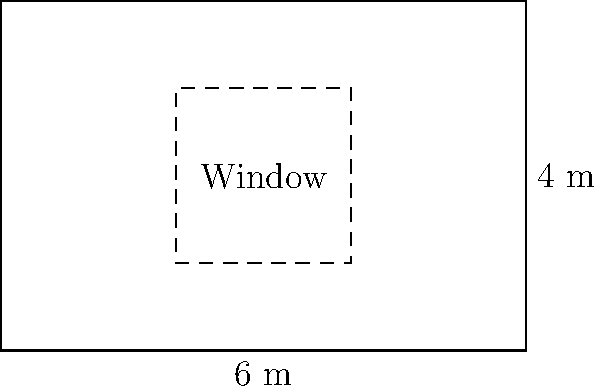You are planning a new mural on a rectangular wall measuring 6 meters wide and 4 meters high. The wall has a rectangular window in the center measuring 2 meters wide and 2 meters high. If one liter of paint covers 10 square meters, how many liters of paint will you need to complete the mural, assuming you don't paint over the window? Let's approach this step-by-step:

1) First, calculate the total area of the wall:
   $A_{wall} = 6 \text{ m} \times 4 \text{ m} = 24 \text{ m}^2$

2) Now, calculate the area of the window:
   $A_{window} = 2 \text{ m} \times 2 \text{ m} = 4 \text{ m}^2$

3) The area to be painted is the difference between these two:
   $A_{paint} = A_{wall} - A_{window} = 24 \text{ m}^2 - 4 \text{ m}^2 = 20 \text{ m}^2$

4) We know that 1 liter of paint covers 10 square meters. To find out how many liters we need, we divide the area to be painted by the area one liter covers:

   $\text{Liters needed} = \frac{A_{paint}}{10 \text{ m}^2/\text{L}} = \frac{20 \text{ m}^2}{10 \text{ m}^2/\text{L}} = 2 \text{ L}$

Therefore, you will need 2 liters of paint to complete the mural.
Answer: 2 L 